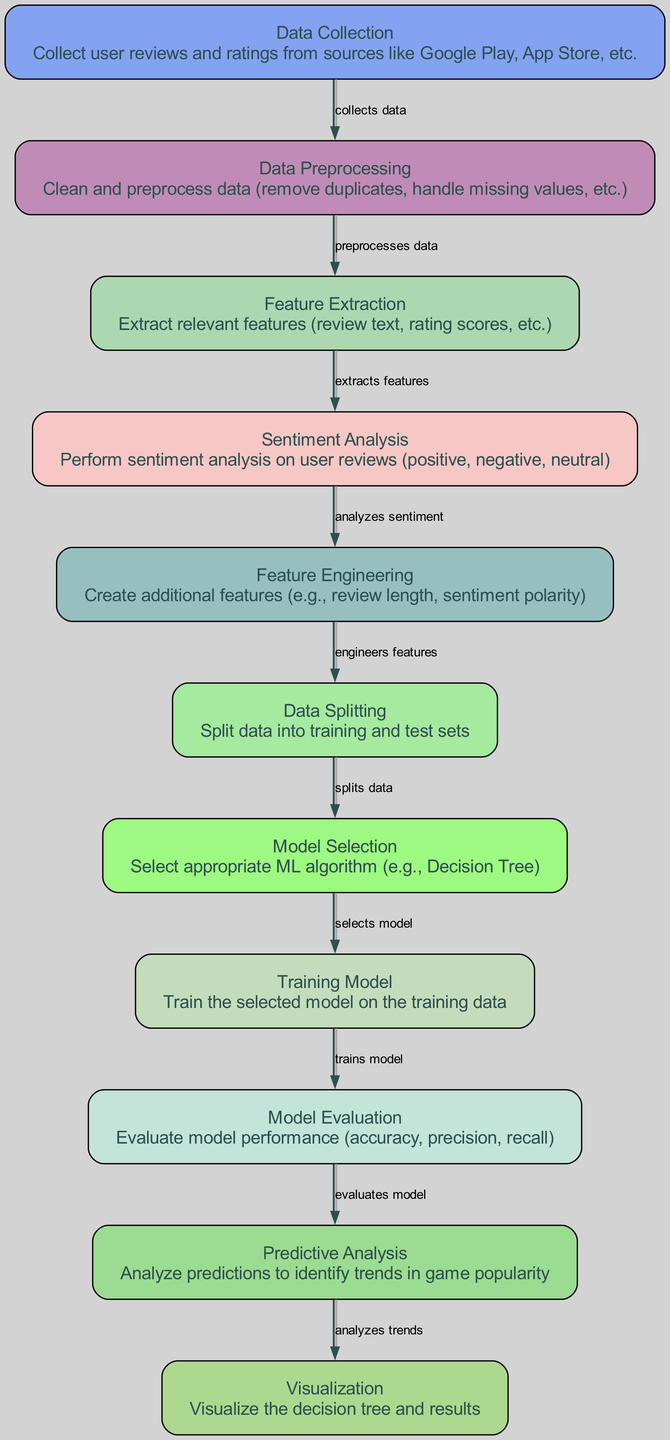What is the first stage in the diagram? The first stage in the diagram is labeled "Data Collection", which is identified as the starting node that collects user reviews and ratings.
Answer: Data Collection How many nodes are present in the diagram? By counting the unique labeled stages in the diagram, we see there are 11 nodes present that involve various stages in the analysis process.
Answer: 11 What node follows "Sentiment Analysis"? The node that follows "Sentiment Analysis" is "Feature Engineering", which is connected directly through an edge indicating the flow of data and processes.
Answer: Feature Engineering What process does "Data Splitting" lead to? "Data Splitting" leads to "Model Selection", as it divides the dataset into training and test sets before selecting the appropriate machine learning model.
Answer: Model Selection What type of analysis is done after evaluating the model? After evaluating the model, "Predictive Analysis" is performed to analyze the predictions and identify trends in mobile game popularity.
Answer: Predictive Analysis Which node indicates the visualization of the decision tree? The node indicating the visualization of the decision tree is labeled "Visualization", which presents the results and insights derived from the analysis process.
Answer: Visualization How many edges are there in the diagram? By counting the connections between the various nodes, there are a total of 10 edges illustrated in the flow of the analysis process.
Answer: 10 Which stage involves cleaning the collected data? The stage that involves cleaning the collected data is labeled "Data Preprocessing", which is essential for preparing the data for further analysis.
Answer: Data Preprocessing What feature is created in the "Feature Engineering" node? In the "Feature Engineering" node, additional features such as review length and sentiment polarity are created to enrich the dataset for analysis.
Answer: Review length and sentiment polarity Which stage follows "Model Evaluation"? The stage that follows "Model Evaluation" is "Predictive Analysis", which utilizes the evaluated model to derive insights about game popularity.
Answer: Predictive Analysis 